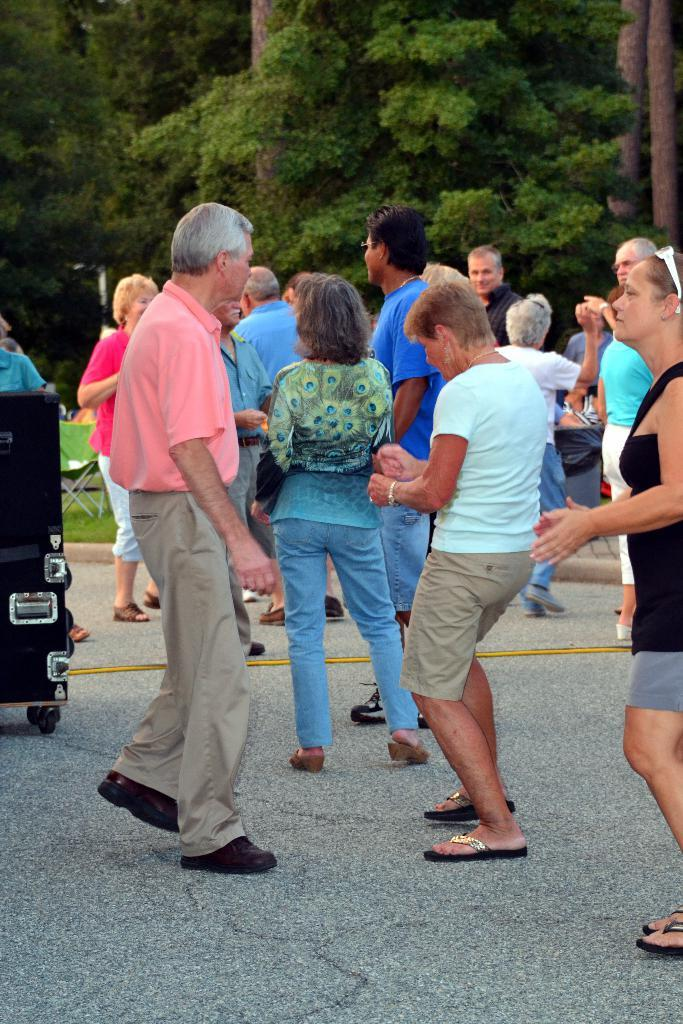Who or what can be seen in the image? There are people in the image. What else is present in the image besides the people? There are other objects in the image. What can be seen in the background of the image? There are trees, poles, and grass in the background of the image. What is at the bottom of the image? There is grass at the bottom of the image. What type of jewel can be seen on the person's neck in the image? There is no jewel visible on anyone's neck in the image. What type of pear is being used to create the print on the person's shirt in the image? There is no pear or print on any person's shirt in the image. 